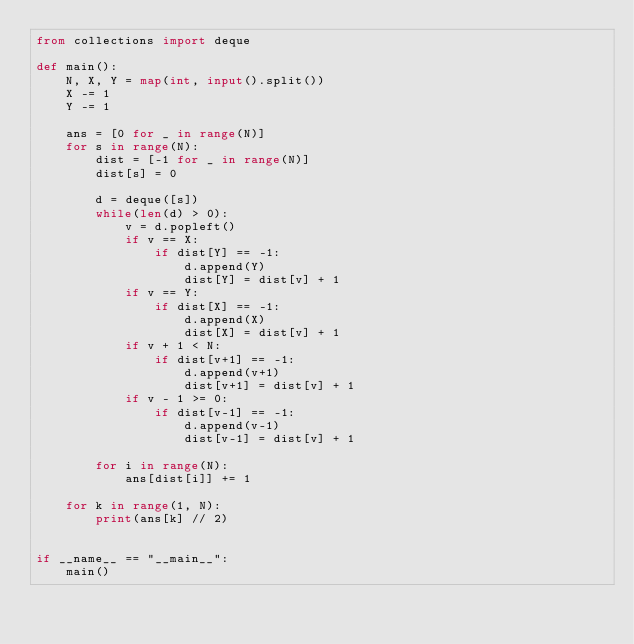Convert code to text. <code><loc_0><loc_0><loc_500><loc_500><_Python_>from collections import deque

def main():
    N, X, Y = map(int, input().split())
    X -= 1
    Y -= 1

    ans = [0 for _ in range(N)]
    for s in range(N):
        dist = [-1 for _ in range(N)]
        dist[s] = 0

        d = deque([s])
        while(len(d) > 0):
            v = d.popleft()
            if v == X:
                if dist[Y] == -1:
                    d.append(Y)
                    dist[Y] = dist[v] + 1
            if v == Y:
                if dist[X] == -1:
                    d.append(X)
                    dist[X] = dist[v] + 1
            if v + 1 < N:
                if dist[v+1] == -1:
                    d.append(v+1)
                    dist[v+1] = dist[v] + 1
            if v - 1 >= 0:
                if dist[v-1] == -1:
                    d.append(v-1)
                    dist[v-1] = dist[v] + 1

        for i in range(N):
            ans[dist[i]] += 1
  
    for k in range(1, N):
        print(ans[k] // 2)


if __name__ == "__main__":
    main()</code> 